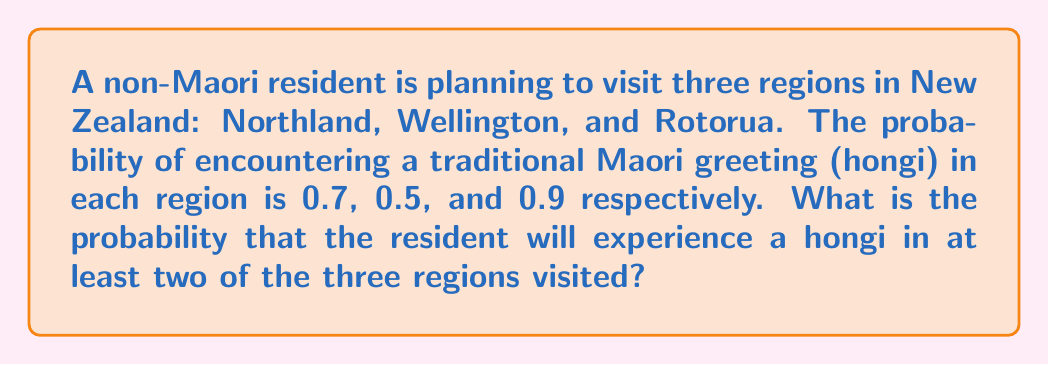Help me with this question. To solve this problem, we can use the concept of probability and the complement rule. Let's break it down step-by-step:

1. First, let's define our events:
   $A$: Experience hongi in Northland (probability = 0.7)
   $B$: Experience hongi in Wellington (probability = 0.5)
   $C$: Experience hongi in Rotorua (probability = 0.9)

2. We want to find the probability of experiencing hongi in at least two regions. It's easier to calculate the complement of this event, which is experiencing hongi in one or zero regions, and then subtract from 1.

3. Probability of experiencing hongi in zero regions:
   $P(\text{no hongi}) = (1-0.7) \times (1-0.5) \times (1-0.9) = 0.3 \times 0.5 \times 0.1 = 0.015$

4. Probability of experiencing hongi in exactly one region:
   $P(\text{only A}) = 0.7 \times 0.5 \times 0.1 = 0.035$
   $P(\text{only B}) = 0.3 \times 0.5 \times 0.1 = 0.015$
   $P(\text{only C}) = 0.3 \times 0.5 \times 0.9 = 0.135$

   $P(\text{exactly one}) = 0.035 + 0.015 + 0.135 = 0.185$

5. Probability of experiencing hongi in one or zero regions:
   $P(\text{one or zero}) = 0.015 + 0.185 = 0.2$

6. Therefore, the probability of experiencing hongi in at least two regions is:
   $P(\text{at least two}) = 1 - P(\text{one or zero}) = 1 - 0.2 = 0.8$
Answer: The probability that the resident will experience a hongi in at least two of the three regions visited is 0.8 or 80%. 